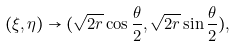Convert formula to latex. <formula><loc_0><loc_0><loc_500><loc_500>( \xi , \eta ) \rightarrow ( \sqrt { 2 r } \cos \frac { \theta } { 2 } , \sqrt { 2 r } \sin \frac { \theta } { 2 } ) ,</formula> 